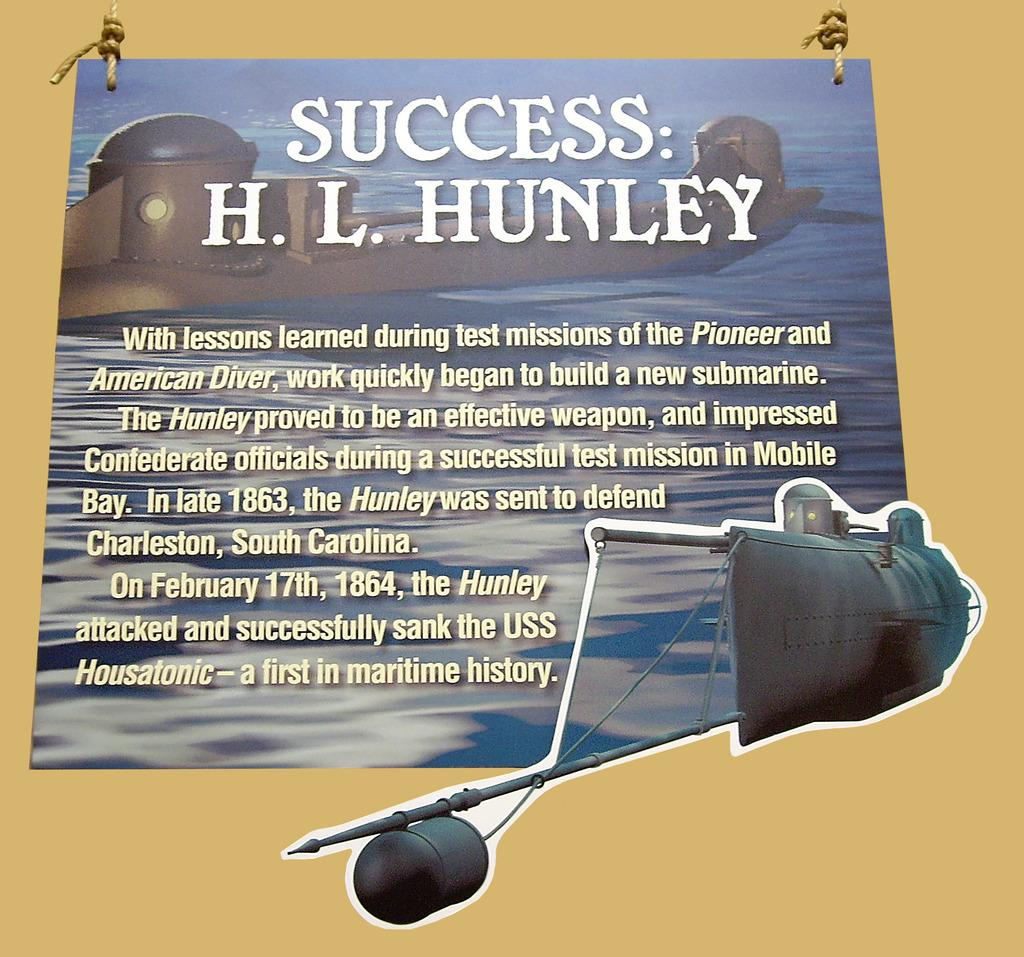<image>
Create a compact narrative representing the image presented. A motivational poster about success and the HL Hunley. 